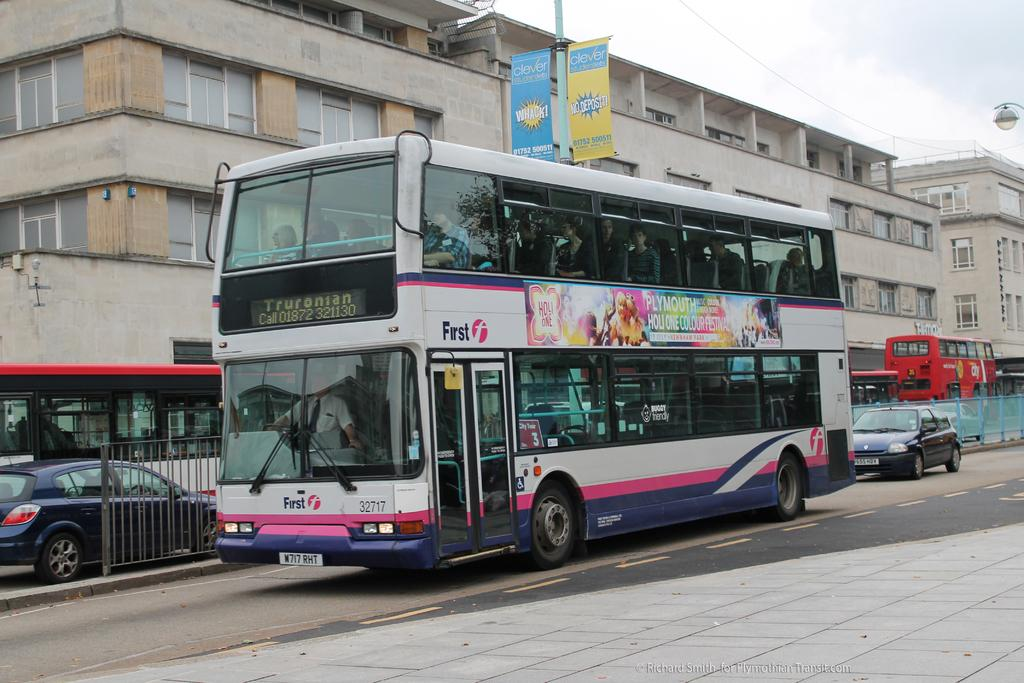<image>
Give a short and clear explanation of the subsequent image. A double decker bus has the word First on the side of it. 